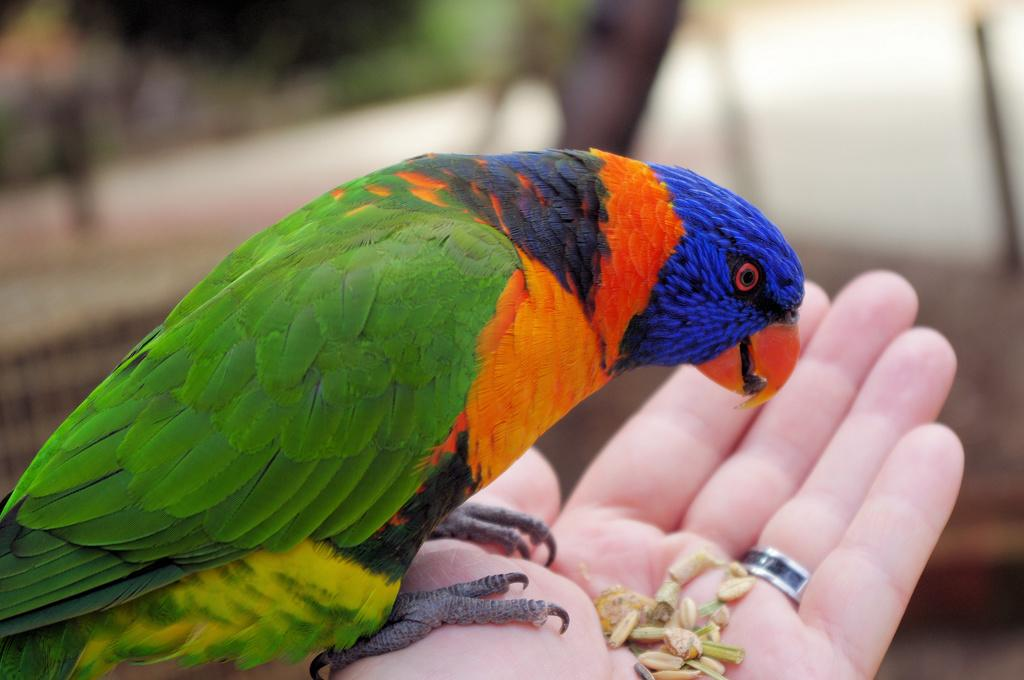What type of animal can be seen in the image? There is a bird in the image. What is the bird interacting with in the image? Grains are present on a human hand in the image, which the bird may be interacting with. Can you describe the background of the image? The background of the image is blurred. How many rests does the bird take on the bed in the image? There is no bed or rests mentioned in the image; it features a bird interacting with grains on a human hand. What is the amount of grains on the bed in the image? There is no bed or grains on a bed mentioned in the image; it features grains on a human hand. 